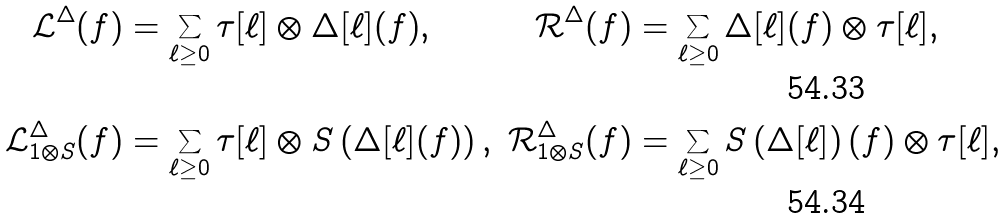Convert formula to latex. <formula><loc_0><loc_0><loc_500><loc_500>\mathcal { L } ^ { \Delta } ( f ) & = \sum _ { \ell \geq 0 } \tau [ \ell ] \otimes \Delta [ \ell ] ( f ) , & \mathcal { R } ^ { \Delta } ( f ) & = \sum _ { \ell \geq 0 } \Delta [ \ell ] ( f ) \otimes \tau [ \ell ] , \\ \mathcal { L } ^ { \Delta } _ { 1 \otimes S } ( f ) & = \sum _ { \ell \geq 0 } \tau [ \ell ] \otimes S \left ( \Delta [ \ell ] ( f ) \right ) , & \mathcal { R } ^ { \Delta } _ { 1 \otimes S } ( f ) & = \sum _ { \ell \geq 0 } S \left ( \Delta [ \ell ] \right ) ( f ) \otimes \tau [ \ell ] ,</formula> 